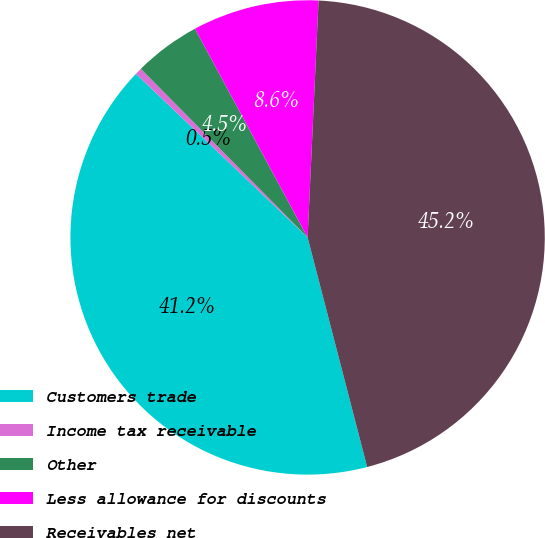<chart> <loc_0><loc_0><loc_500><loc_500><pie_chart><fcel>Customers trade<fcel>Income tax receivable<fcel>Other<fcel>Less allowance for discounts<fcel>Receivables net<nl><fcel>41.16%<fcel>0.47%<fcel>4.54%<fcel>8.61%<fcel>45.23%<nl></chart> 